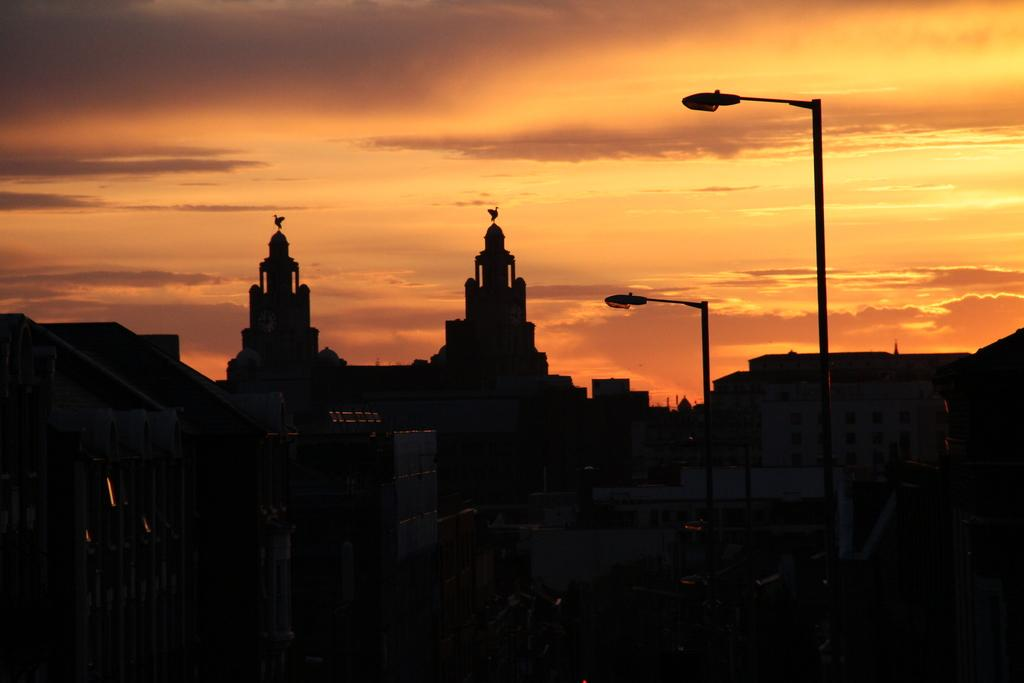What type of location is depicted in the image? The image depicts a city. What structures can be seen in the city? There are buildings in the image. Are there any other objects present in the cityscape? Yes, there are poles in the image. What decorative elements can be seen on the buildings? The buildings have sculptures of birds on them. What is visible at the top of the image? The sky is visible at the top of the image. Can you describe the sky in the image? The sky has clouds in it. What type of coil can be seen wrapped around the buildings in the image? There is no coil present in the image; it depicts a city with buildings, poles, and bird sculptures. How many drops of water are visible on the glass in the image? There is no glass present in the image; it shows a city with a sky featuring clouds. 